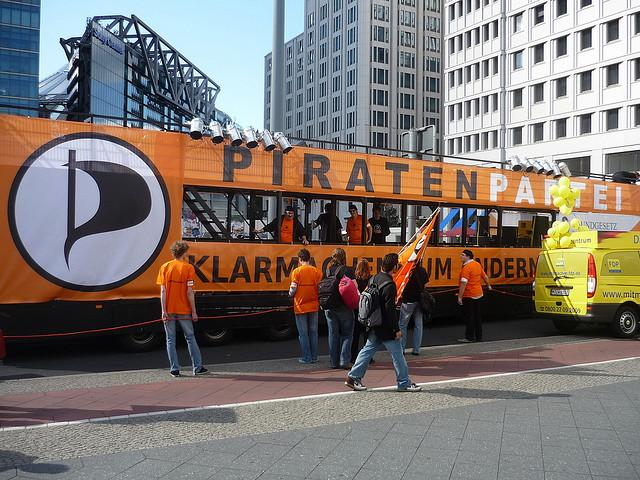What fun item can be seen in the photo? Please explain your reasoning. balloons. Balloons are festive. 